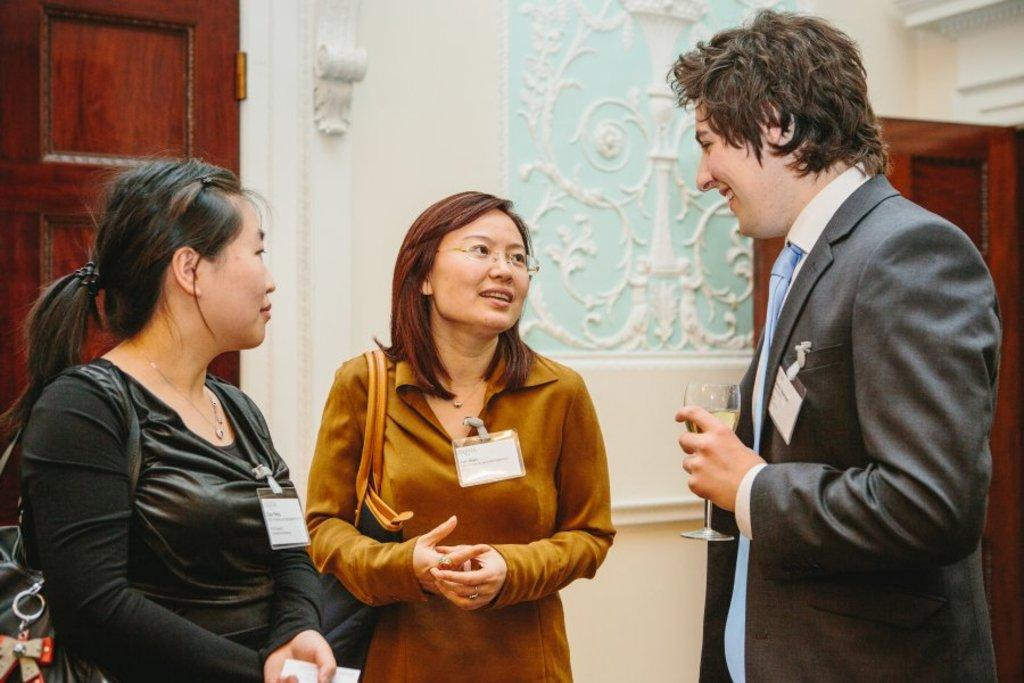How many people are in the image? There are two women and a man in the image. What is the man holding in his hand? The man is holding a glass in his hand. What can be seen in the background of the image? There is a wall in the background of the image. Are there any openings in the wall? Yes, there are doors in the wall. Reasoning: Let's think step by step by step in order to produce the conversation. We start by identifying the number of people in the image and their genders. Then, we focus on the man and describe what he is holding in his hand. Next, we shift our attention to the background and mention the presence of a wall. Finally, we provide information about the wall by mentioning the doors. Absurd Question/Answer: What word is being spoken by the man in the image? There is no indication in the image of what the man might be saying, so it cannot be determined from the picture. --- Facts: 1. There is a car in the image. 2. The car is red. 3. The car has four wheels. 4. There is a road in the image. 5. The road is paved. Absurd Topics: bird, ocean, mountain Conversation: What is the main subject of the image? The main subject of the image is a car. What color is the car? The car is red. How many wheels does the car have? The car has four wheels. What can be seen in the background of the image? There is a road in the image. What is the condition of the road? The road is paved. Can you see any mountains in the image? There are no mountains present in the image; it features a red car and a paved road. What type of bird is flying over the car in the image? There is no bird present in the image. --- Facts: 1. There is a dog in the image. 2. The dog is sitting on a chair. 3. The chair has a patterned fabric. 4. There is a window in the background of the image. 5. The window has curtains. Absurd Topics: fish, bicycle, rainbow Conversation: What animal is in the image? There is a dog in the image. What is the dog doing in the image? The dog is sitting on a chair. Can you describe the chair the dog is sitting on? The chair has a patterned fabric. What can be seen in the background of the image? There is a window in the background of the image. What is the window's condition? The window has curtains. Reasoning: Let's think step by step in order to produce the conversation. We start 